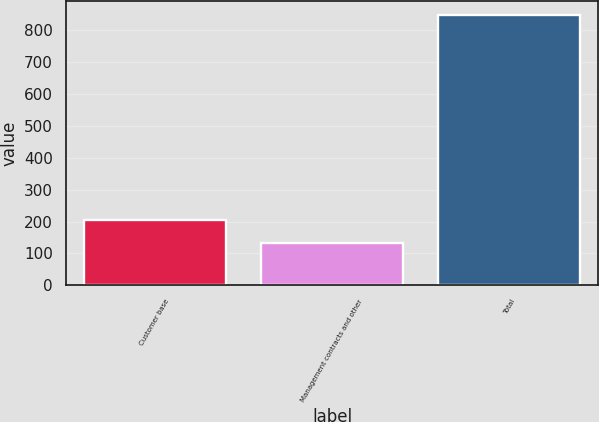<chart> <loc_0><loc_0><loc_500><loc_500><bar_chart><fcel>Customer base<fcel>Management contracts and other<fcel>Total<nl><fcel>205.68<fcel>134.2<fcel>849<nl></chart> 